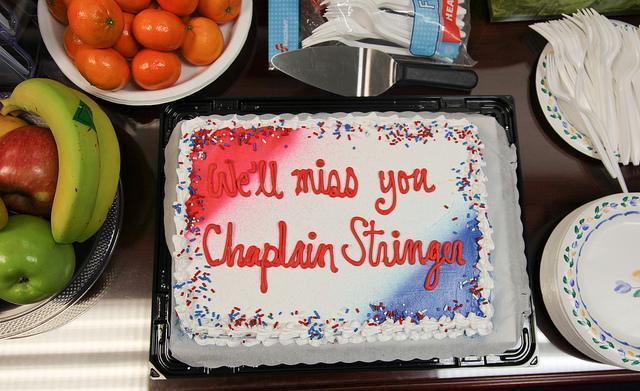How many different type of fruits can you clearly see in this picture?
Give a very brief answer. 3. How many apples can be seen?
Give a very brief answer. 2. How many bananas are in the photo?
Give a very brief answer. 2. 